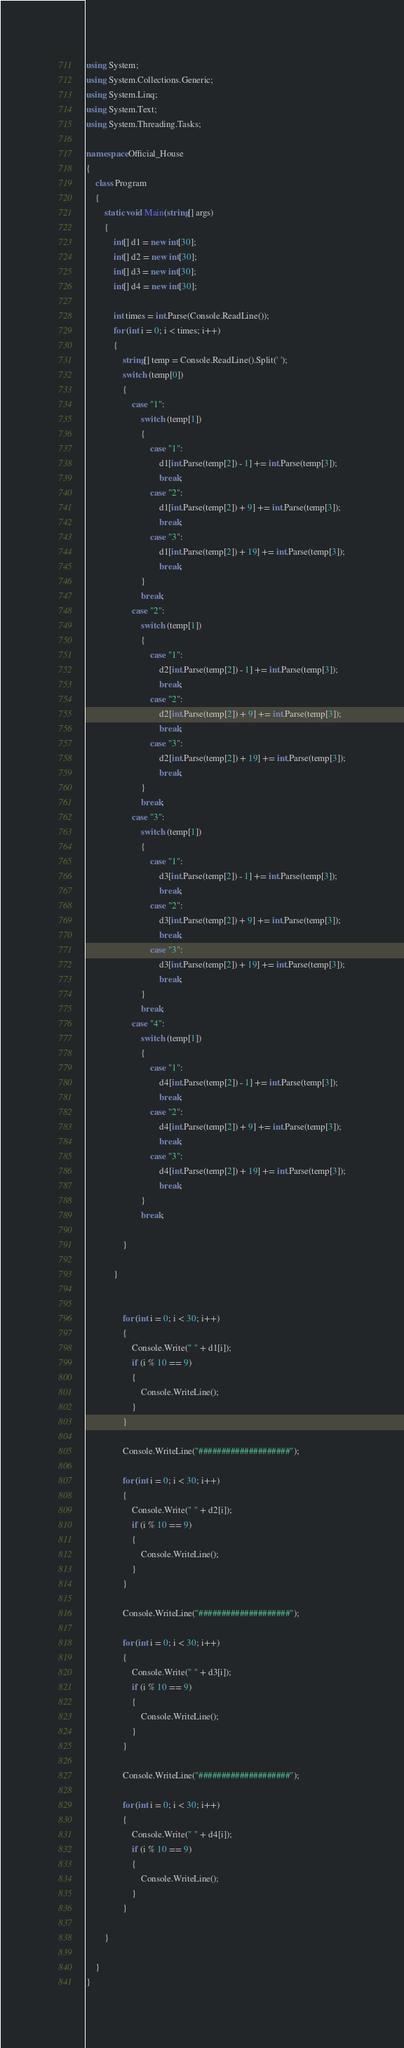<code> <loc_0><loc_0><loc_500><loc_500><_C#_>using System;
using System.Collections.Generic;
using System.Linq;
using System.Text;
using System.Threading.Tasks;

namespace Official_House
{
    class Program
    {
        static void Main(string[] args)
        {
            int[] d1 = new int[30];
            int[] d2 = new int[30];
            int[] d3 = new int[30];
            int[] d4 = new int[30];

            int times = int.Parse(Console.ReadLine());
            for (int i = 0; i < times; i++)
            {
                string[] temp = Console.ReadLine().Split(' ');
                switch (temp[0])
                { 
                    case "1":
                        switch (temp[1])
                        { 
                            case "1":
                                d1[int.Parse(temp[2]) - 1] += int.Parse(temp[3]);
                                break;
                            case "2":
                                d1[int.Parse(temp[2]) + 9] += int.Parse(temp[3]);
                                break;
                            case "3":
                                d1[int.Parse(temp[2]) + 19] += int.Parse(temp[3]);
                                break;
                        }
                        break;
                    case "2":
                        switch (temp[1])
                        { 
                            case "1":
                                d2[int.Parse(temp[2]) - 1] += int.Parse(temp[3]);
                                break;
                            case "2":
                                d2[int.Parse(temp[2]) + 9] += int.Parse(temp[3]);
                                break;
                            case "3":
                                d2[int.Parse(temp[2]) + 19] += int.Parse(temp[3]);
                                break;
                        }
                        break;
                    case "3":
                        switch (temp[1])
                        {
                            case "1":
                                d3[int.Parse(temp[2]) - 1] += int.Parse(temp[3]);
                                break;
                            case "2":
                                d3[int.Parse(temp[2]) + 9] += int.Parse(temp[3]);
                                break;
                            case "3":
                                d3[int.Parse(temp[2]) + 19] += int.Parse(temp[3]);
                                break;
                        }
                        break;
                    case "4":
                        switch (temp[1])
                        {
                            case "1":
                                d4[int.Parse(temp[2]) - 1] += int.Parse(temp[3]);
                                break;
                            case "2":
                                d4[int.Parse(temp[2]) + 9] += int.Parse(temp[3]);
                                break;
                            case "3":
                                d4[int.Parse(temp[2]) + 19] += int.Parse(temp[3]);
                                break;
                        }
                        break;

                }

            }


                for (int i = 0; i < 30; i++)
                {
                    Console.Write(" " + d1[i]);
                    if (i % 10 == 9)
                    {
                        Console.WriteLine();
                    }
                }

                Console.WriteLine("####################");

                for (int i = 0; i < 30; i++)
                {
                    Console.Write(" " + d2[i]);
                    if (i % 10 == 9)
                    {
                        Console.WriteLine();
                    }
                }

                Console.WriteLine("####################");

                for (int i = 0; i < 30; i++)
                {
                    Console.Write(" " + d3[i]);
                    if (i % 10 == 9)
                    {
                        Console.WriteLine();
                    }
                }

                Console.WriteLine("####################");

                for (int i = 0; i < 30; i++)
                {
                    Console.Write(" " + d4[i]);
                    if (i % 10 == 9)
                    {
                        Console.WriteLine();
                    }
                }

        }

    }
}

</code> 